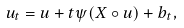Convert formula to latex. <formula><loc_0><loc_0><loc_500><loc_500>u _ { t } = u + t \psi ( X \circ u ) + b _ { t } ,</formula> 